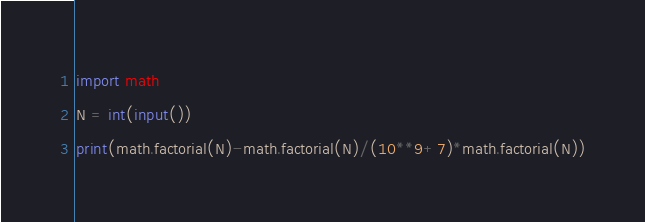Convert code to text. <code><loc_0><loc_0><loc_500><loc_500><_Python_>import math
N = int(input())
print(math.factorial(N)-math.factorial(N)/(10**9+7)*math.factorial(N))</code> 